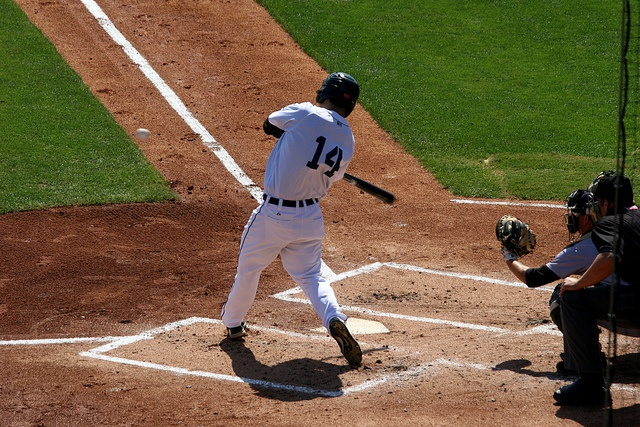Describe the objects in this image and their specific colors. I can see people in darkgreen, gray, and black tones, people in darkgreen, black, maroon, and gray tones, people in darkgreen, black, navy, maroon, and gray tones, baseball glove in darkgreen, black, maroon, and gray tones, and baseball bat in darkgreen, black, and gray tones in this image. 